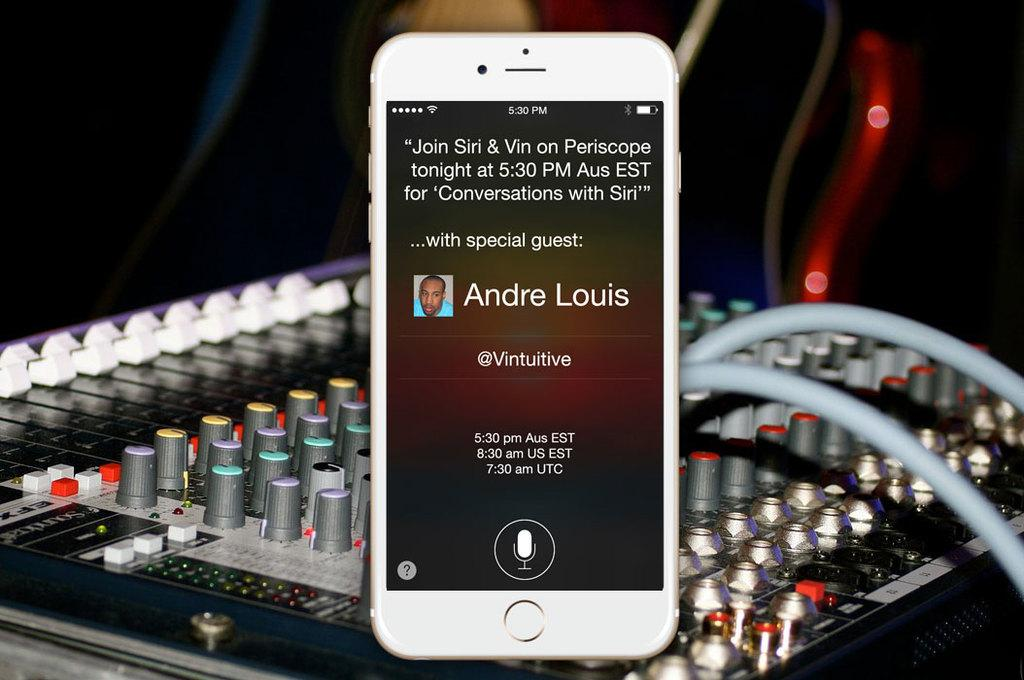<image>
Give a short and clear explanation of the subsequent image. Cell phone with contact screen open calling Andre Louis 